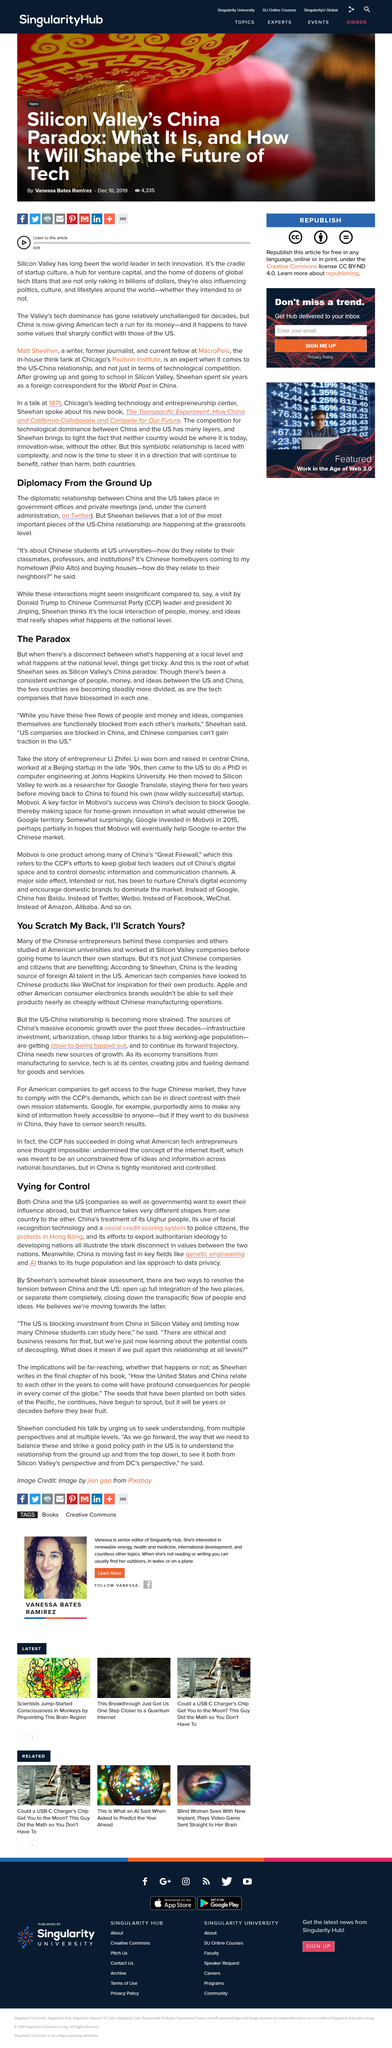Specify some key components in this picture. Yes, the fact that China is the leading source of foreign AI talent in the US is an example of the principle of "you scratch my back, I'll scratch yours. American tech companies have been inspired by Chinese products like WeChat and have incorporated similar features into their own products. It is a well-known fact that a significant number of Chinese entrepreneurs have obtained their higher education in American universities. Companies that are blocked in China, according to Sheehan, are primarily US-based. According to Sheehan, the grassroots of US-China relationships are composed of Chinese students at US universities and Chinese homebuyers who purchase houses in the United States. 